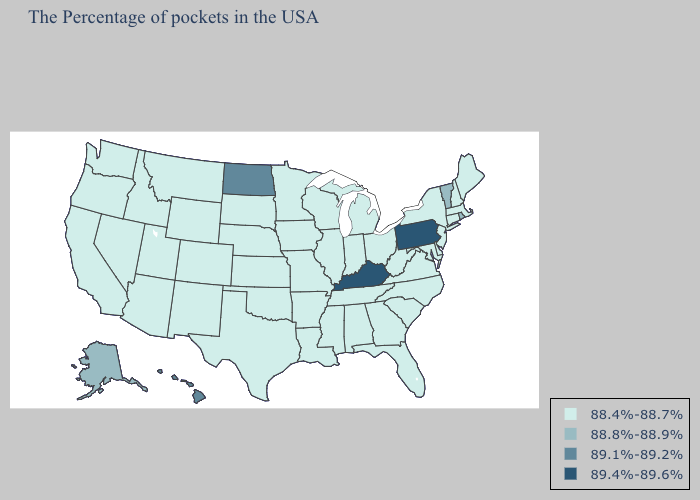What is the lowest value in states that border Illinois?
Quick response, please. 88.4%-88.7%. Does Tennessee have the highest value in the USA?
Keep it brief. No. Name the states that have a value in the range 89.1%-89.2%?
Concise answer only. North Dakota, Hawaii. Does Nevada have the lowest value in the USA?
Quick response, please. Yes. What is the value of Indiana?
Write a very short answer. 88.4%-88.7%. What is the lowest value in states that border New Jersey?
Answer briefly. 88.4%-88.7%. What is the lowest value in the South?
Concise answer only. 88.4%-88.7%. Name the states that have a value in the range 88.4%-88.7%?
Concise answer only. Maine, Massachusetts, New Hampshire, Connecticut, New York, New Jersey, Delaware, Maryland, Virginia, North Carolina, South Carolina, West Virginia, Ohio, Florida, Georgia, Michigan, Indiana, Alabama, Tennessee, Wisconsin, Illinois, Mississippi, Louisiana, Missouri, Arkansas, Minnesota, Iowa, Kansas, Nebraska, Oklahoma, Texas, South Dakota, Wyoming, Colorado, New Mexico, Utah, Montana, Arizona, Idaho, Nevada, California, Washington, Oregon. How many symbols are there in the legend?
Short answer required. 4. What is the value of Maryland?
Be succinct. 88.4%-88.7%. Which states have the lowest value in the Northeast?
Write a very short answer. Maine, Massachusetts, New Hampshire, Connecticut, New York, New Jersey. What is the value of Nebraska?
Answer briefly. 88.4%-88.7%. Name the states that have a value in the range 89.1%-89.2%?
Give a very brief answer. North Dakota, Hawaii. Name the states that have a value in the range 88.8%-88.9%?
Short answer required. Rhode Island, Vermont, Alaska. What is the value of Massachusetts?
Concise answer only. 88.4%-88.7%. 